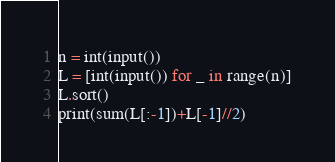<code> <loc_0><loc_0><loc_500><loc_500><_Python_>n = int(input())
L = [int(input()) for _ in range(n)]
L.sort()
print(sum(L[:-1])+L[-1]//2)</code> 